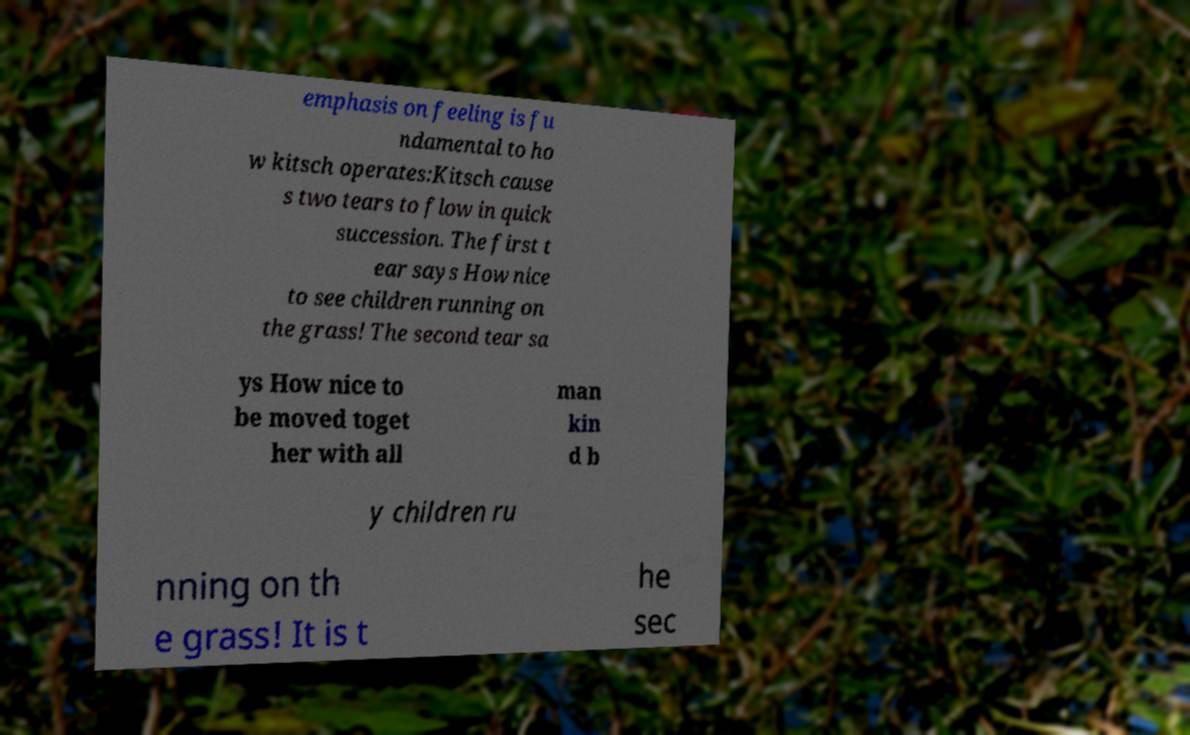For documentation purposes, I need the text within this image transcribed. Could you provide that? emphasis on feeling is fu ndamental to ho w kitsch operates:Kitsch cause s two tears to flow in quick succession. The first t ear says How nice to see children running on the grass! The second tear sa ys How nice to be moved toget her with all man kin d b y children ru nning on th e grass! It is t he sec 